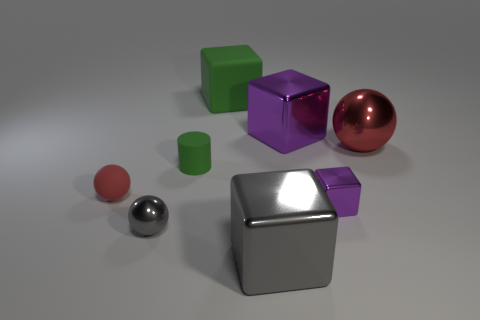Is the gray metal ball the same size as the red rubber object?
Offer a terse response. Yes. There is a object that is in front of the tiny metallic cube and behind the gray metal cube; how big is it?
Offer a terse response. Small. How many big balls have the same material as the small block?
Your answer should be compact. 1. What is the shape of the large thing that is the same color as the rubber cylinder?
Your answer should be very brief. Cube. What is the color of the matte cylinder?
Provide a succinct answer. Green. There is a rubber thing that is behind the large purple metallic block; does it have the same shape as the tiny gray metal object?
Your answer should be compact. No. What number of objects are either purple metallic cubes behind the rubber sphere or yellow cubes?
Provide a short and direct response. 1. Are there any matte objects that have the same shape as the large gray metallic thing?
Make the answer very short. Yes. The gray shiny thing that is the same size as the rubber cylinder is what shape?
Your response must be concise. Sphere. What is the shape of the purple metallic object behind the small ball behind the tiny purple shiny object that is in front of the big purple shiny cube?
Ensure brevity in your answer.  Cube. 